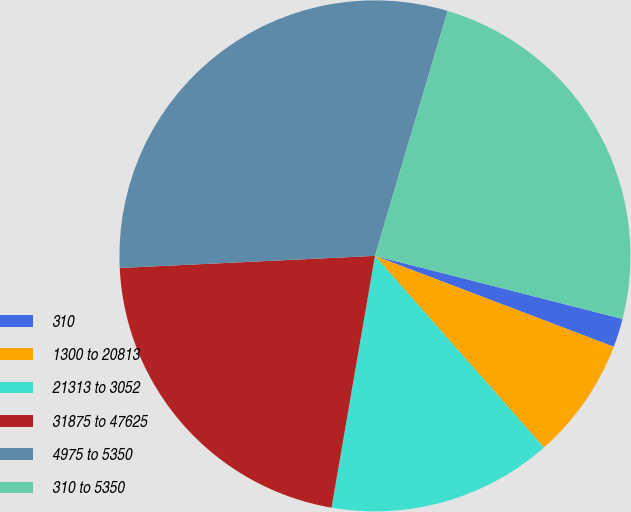Convert chart. <chart><loc_0><loc_0><loc_500><loc_500><pie_chart><fcel>310<fcel>1300 to 20813<fcel>21313 to 3052<fcel>31875 to 47625<fcel>4975 to 5350<fcel>310 to 5350<nl><fcel>1.82%<fcel>7.71%<fcel>14.22%<fcel>21.53%<fcel>30.35%<fcel>24.38%<nl></chart> 